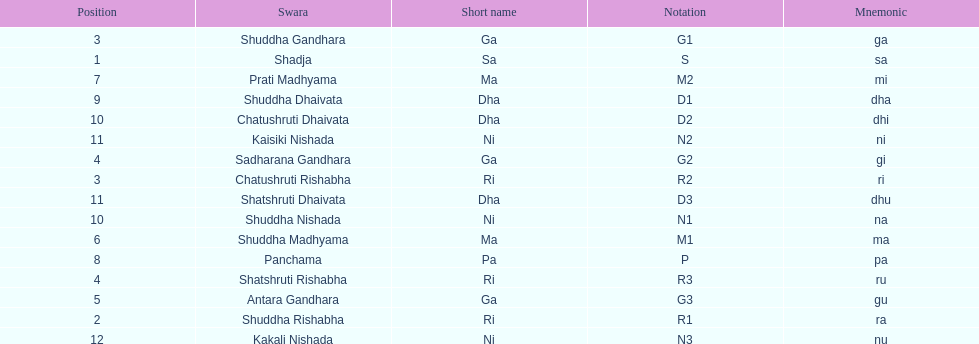What swara is above shatshruti dhaivata? Shuddha Nishada. 